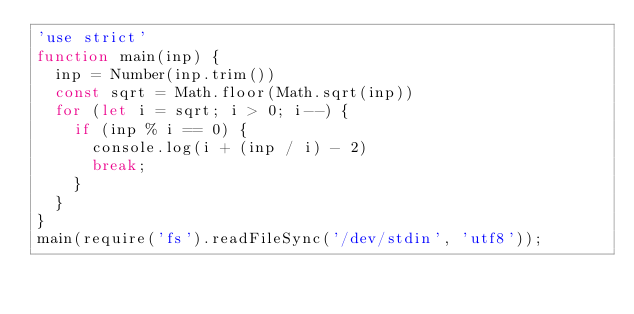Convert code to text. <code><loc_0><loc_0><loc_500><loc_500><_JavaScript_>'use strict'
function main(inp) {
  inp = Number(inp.trim())
  const sqrt = Math.floor(Math.sqrt(inp))
  for (let i = sqrt; i > 0; i--) {
    if (inp % i == 0) {
      console.log(i + (inp / i) - 2)
      break;
    }
  }
}
main(require('fs').readFileSync('/dev/stdin', 'utf8'));
</code> 